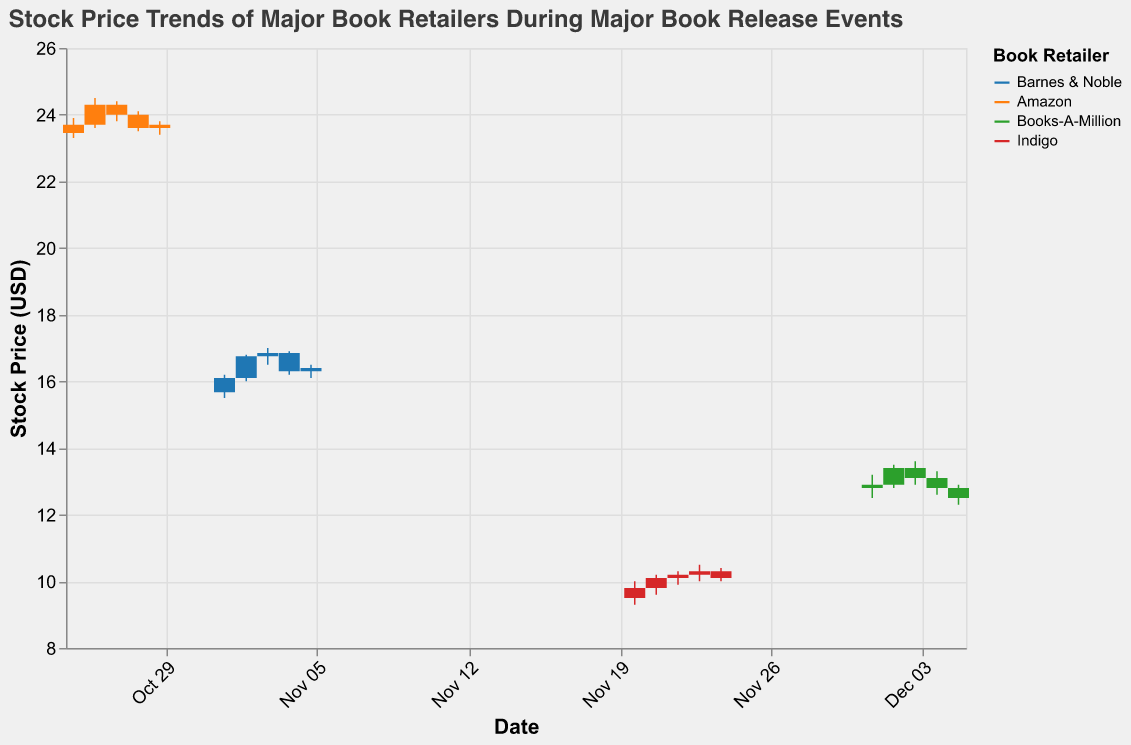What is the title of the figure? The title text displayed at the top of the figure identifies it.
Answer: Stock Price Trends of Major Book Retailers During Major Book Release Events Which retailer has the highest opening price on their respective book release date? Comparing the "Open" values on the release dates for each retailer shows the highest opening price. Amazon has the highest opening price of $23.45 on the release date of "The Midnight Library".
Answer: Amazon On which date did Barnes & Noble experience the highest closing price during the release of 'The Unseen Realm'? Looking at the closing prices of Barnes & Noble during the release of 'The Unseen Realm', the highest closing price was on November 2nd, 2023, with a price of $16.75.
Answer: November 2, 2023 How does the stock price trend of Books-A-Million change over the first three days of 'A Promised Land' release? Observing the candlestick bars for Books-A-Million on the first three days shows the trend: The stock opens at $12.80 on December 1st and closes at $12.90, rises to open at $12.90 on December 2nd and closes at $13.40, then rises to open at $13.40 on December 3rd and closes at $13.10.
Answer: The stock price generally rises and then slightly drops Which retailer experienced the largest volume of trades during the release events, and what was the volume? Comparing the trading volumes during release dates for different retailers, Amazon had the largest volume with 2,500,000 on October 26th, 2023.
Answer: Amazon with 2,500,000 What is the percentage change in the stock price of Indigo from the opening on November 20th to the closing on November 24th? Calculate the percentage change: ((Closing on November 24th - Opening on November 20th) / Opening on November 20th) * 100. The opening price on November 20th is $9.50, and the closing price on November 24th is $10.10. The percentage change is ((10.10 - 9.50) / 9.50) * 100 = 6.32%.
Answer: 6.32% Which book release event showed the most consistent stock price within a narrow range and which retailer does it belong to? Analyzing the high and low prices during the various book releases, 'The Midnight Library' by Amazon shows the most consistent range with high and low prices relatively close together (e.g., October 25th to October 29th).
Answer: 'The Midnight Library', Amazon What was the highest stock price achieved by any retailer during the release events and when was it reached? The highest price was reached by comparing all the "High" values. Amazon achieved the highest stock price of $24.50 on October 26th, 2023.
Answer: $24.50 on October 26, 2023 For which book release did Barnes & Noble experience a drop in closing price following an initial rise? Reviewing the closing prices during the 'The Unseen Realm' release, Barnes & Noble shows an initial price rise from November 1st to November 2nd, then a drop from November 4th to November 5th.
Answer: 'The Unseen Realm' 